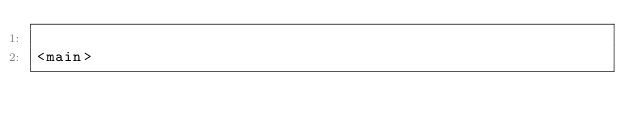Convert code to text. <code><loc_0><loc_0><loc_500><loc_500><_HTML_>
<main>
</code> 